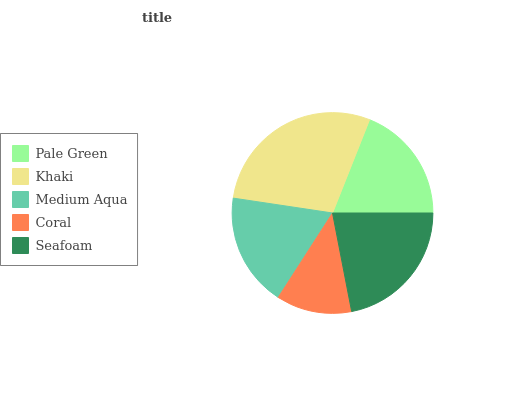Is Coral the minimum?
Answer yes or no. Yes. Is Khaki the maximum?
Answer yes or no. Yes. Is Medium Aqua the minimum?
Answer yes or no. No. Is Medium Aqua the maximum?
Answer yes or no. No. Is Khaki greater than Medium Aqua?
Answer yes or no. Yes. Is Medium Aqua less than Khaki?
Answer yes or no. Yes. Is Medium Aqua greater than Khaki?
Answer yes or no. No. Is Khaki less than Medium Aqua?
Answer yes or no. No. Is Pale Green the high median?
Answer yes or no. Yes. Is Pale Green the low median?
Answer yes or no. Yes. Is Seafoam the high median?
Answer yes or no. No. Is Medium Aqua the low median?
Answer yes or no. No. 